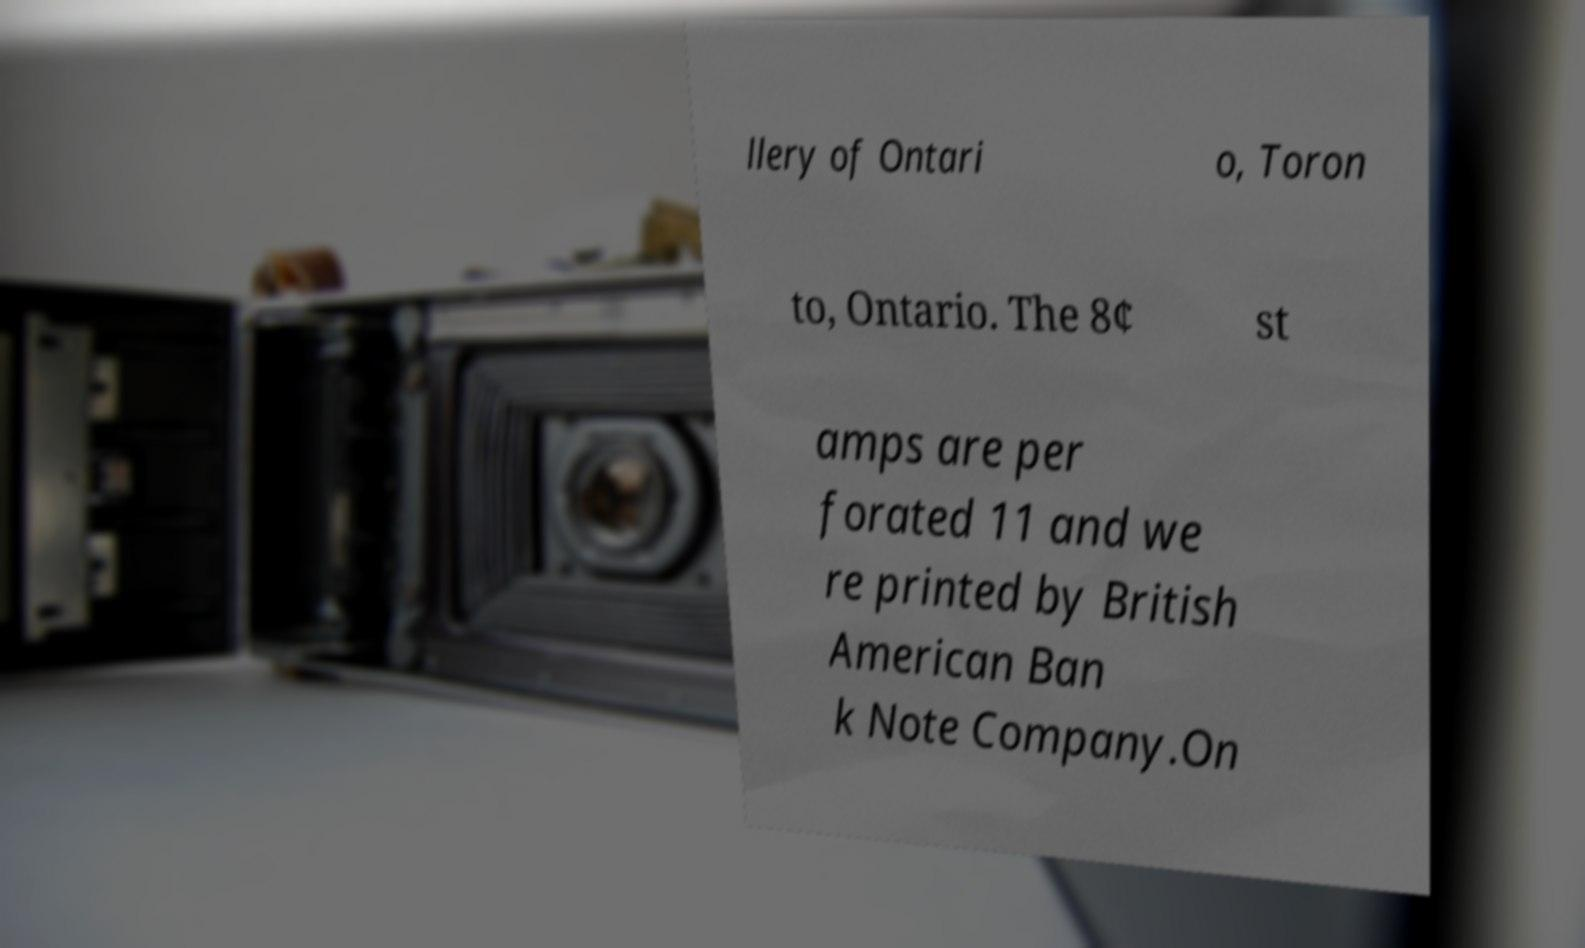Please identify and transcribe the text found in this image. llery of Ontari o, Toron to, Ontario. The 8¢ st amps are per forated 11 and we re printed by British American Ban k Note Company.On 